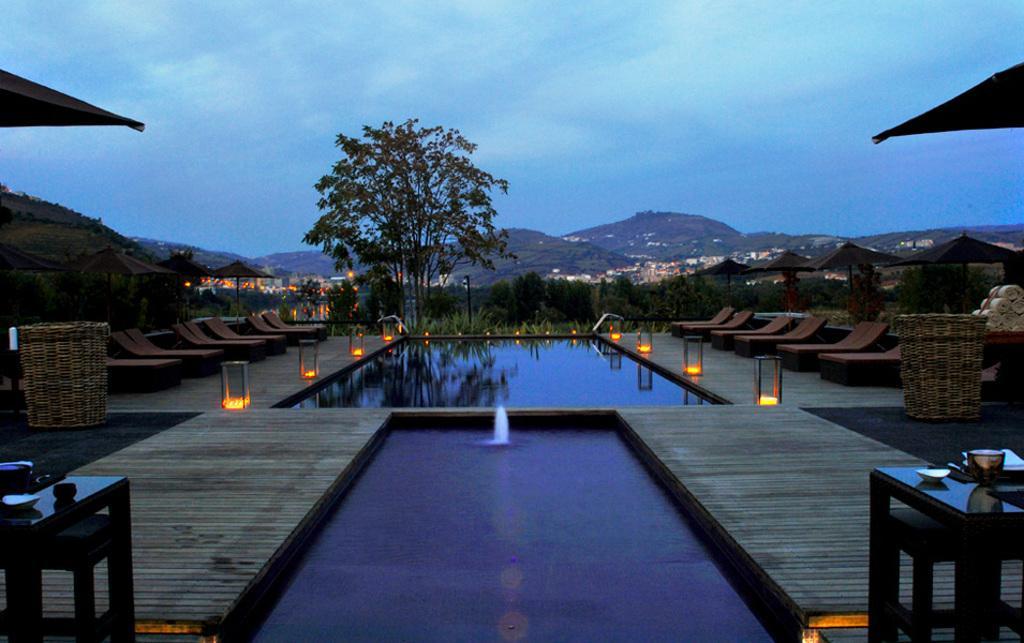How would you summarize this image in a sentence or two? In the center of the image we can see the pools which contains water, beside that we can see the containers, lights. On the left and right side of the image we can see the umbrellas, chairs, boxes, floor. In the bottom right corner we can see a table. On the table we can see some objects. In the bottom left corner we can see a table. On the table we can see some objects. In the background of the image we can see the hills, buildings, trees. At the top of the image we can see the clouds are present in the sky. 